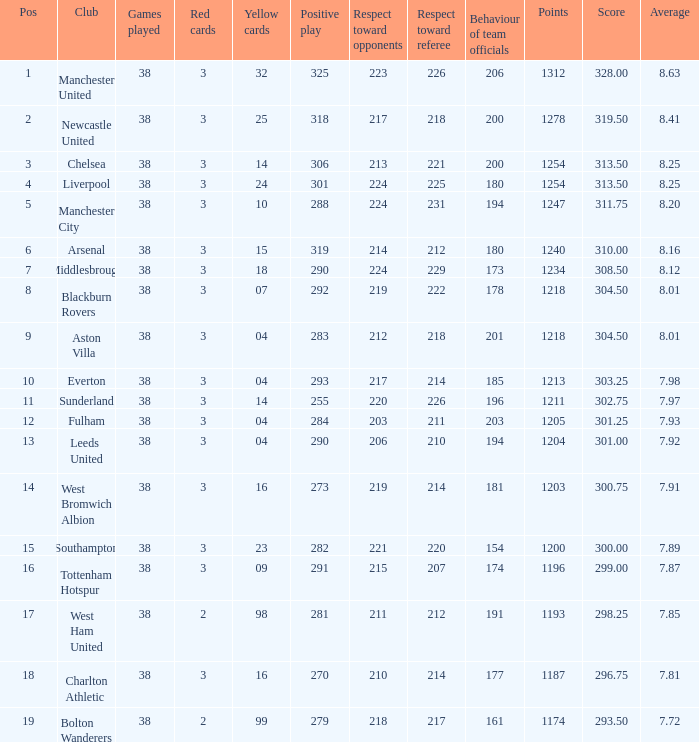Name the pos for west ham united 17.0. 